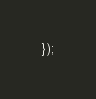Convert code to text. <code><loc_0><loc_0><loc_500><loc_500><_JavaScript_>});
</code> 